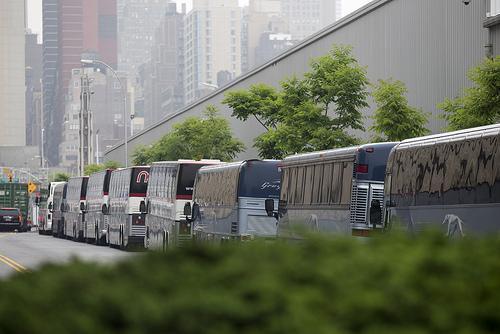How many travel buses can be seen?
Give a very brief answer. 9. 